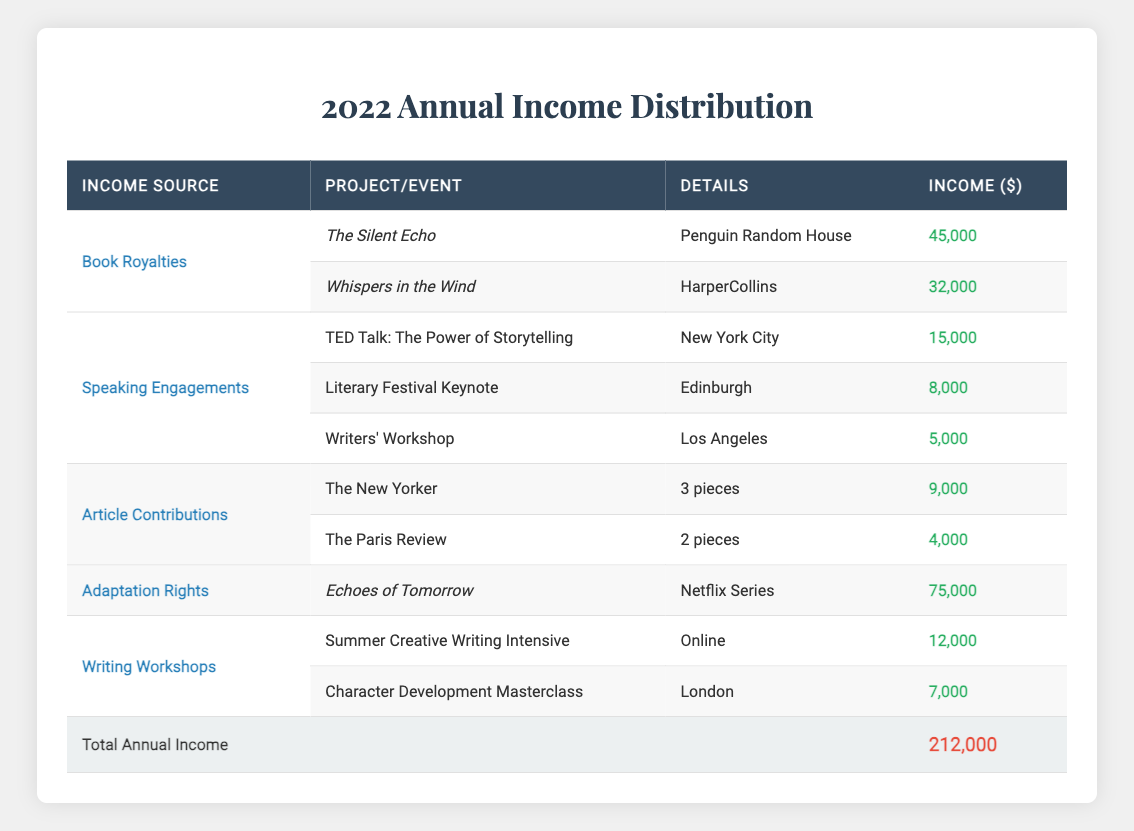What is the total income from Book Royalties? The Book Royalties section has two entries: The Silent Echo ($45,000) and Whispers in the Wind ($32,000). To find the total income from Book Royalties, we add these two amounts: 45,000 + 32,000 = 77,000.
Answer: 77,000 How much did you earn from Speaking Engagements? To find the total income from Speaking Engagements, we look at the entries: TED Talk ($15,000), Literary Festival Keynote ($8,000), and Writers' Workshop ($5,000). Adding these amounts gives: 15,000 + 8,000 + 5,000 = 28,000.
Answer: 28,000 Did you earn more from Adaptation Rights than from Article Contributions? The Adaptation Rights have an income of $75,000, while Article Contributions (from The New Yorker and The Paris Review) total $9,000 + $4,000 = $13,000. Since 75,000 is greater than 13,000, the answer is yes.
Answer: Yes What is the average income from Writing Workshops? There are two entries in the Writing Workshops section: Summer Creative Writing Intensive ($12,000) and Character Development Masterclass ($7,000). To find the average, we add these two incomes: 12,000 + 7,000 = 19,000. Since there are 2 entries, we divide by 2: 19,000 / 2 = 9,500.
Answer: 9,500 Which income type had the highest individual project income? The Adaptation Rights category has an individual project, Echoes of Tomorrow, that earned $75,000. This is higher than any individual entries in other categories, confirming that Adaptation Rights had the highest income for a single project.
Answer: Adaptation Rights 